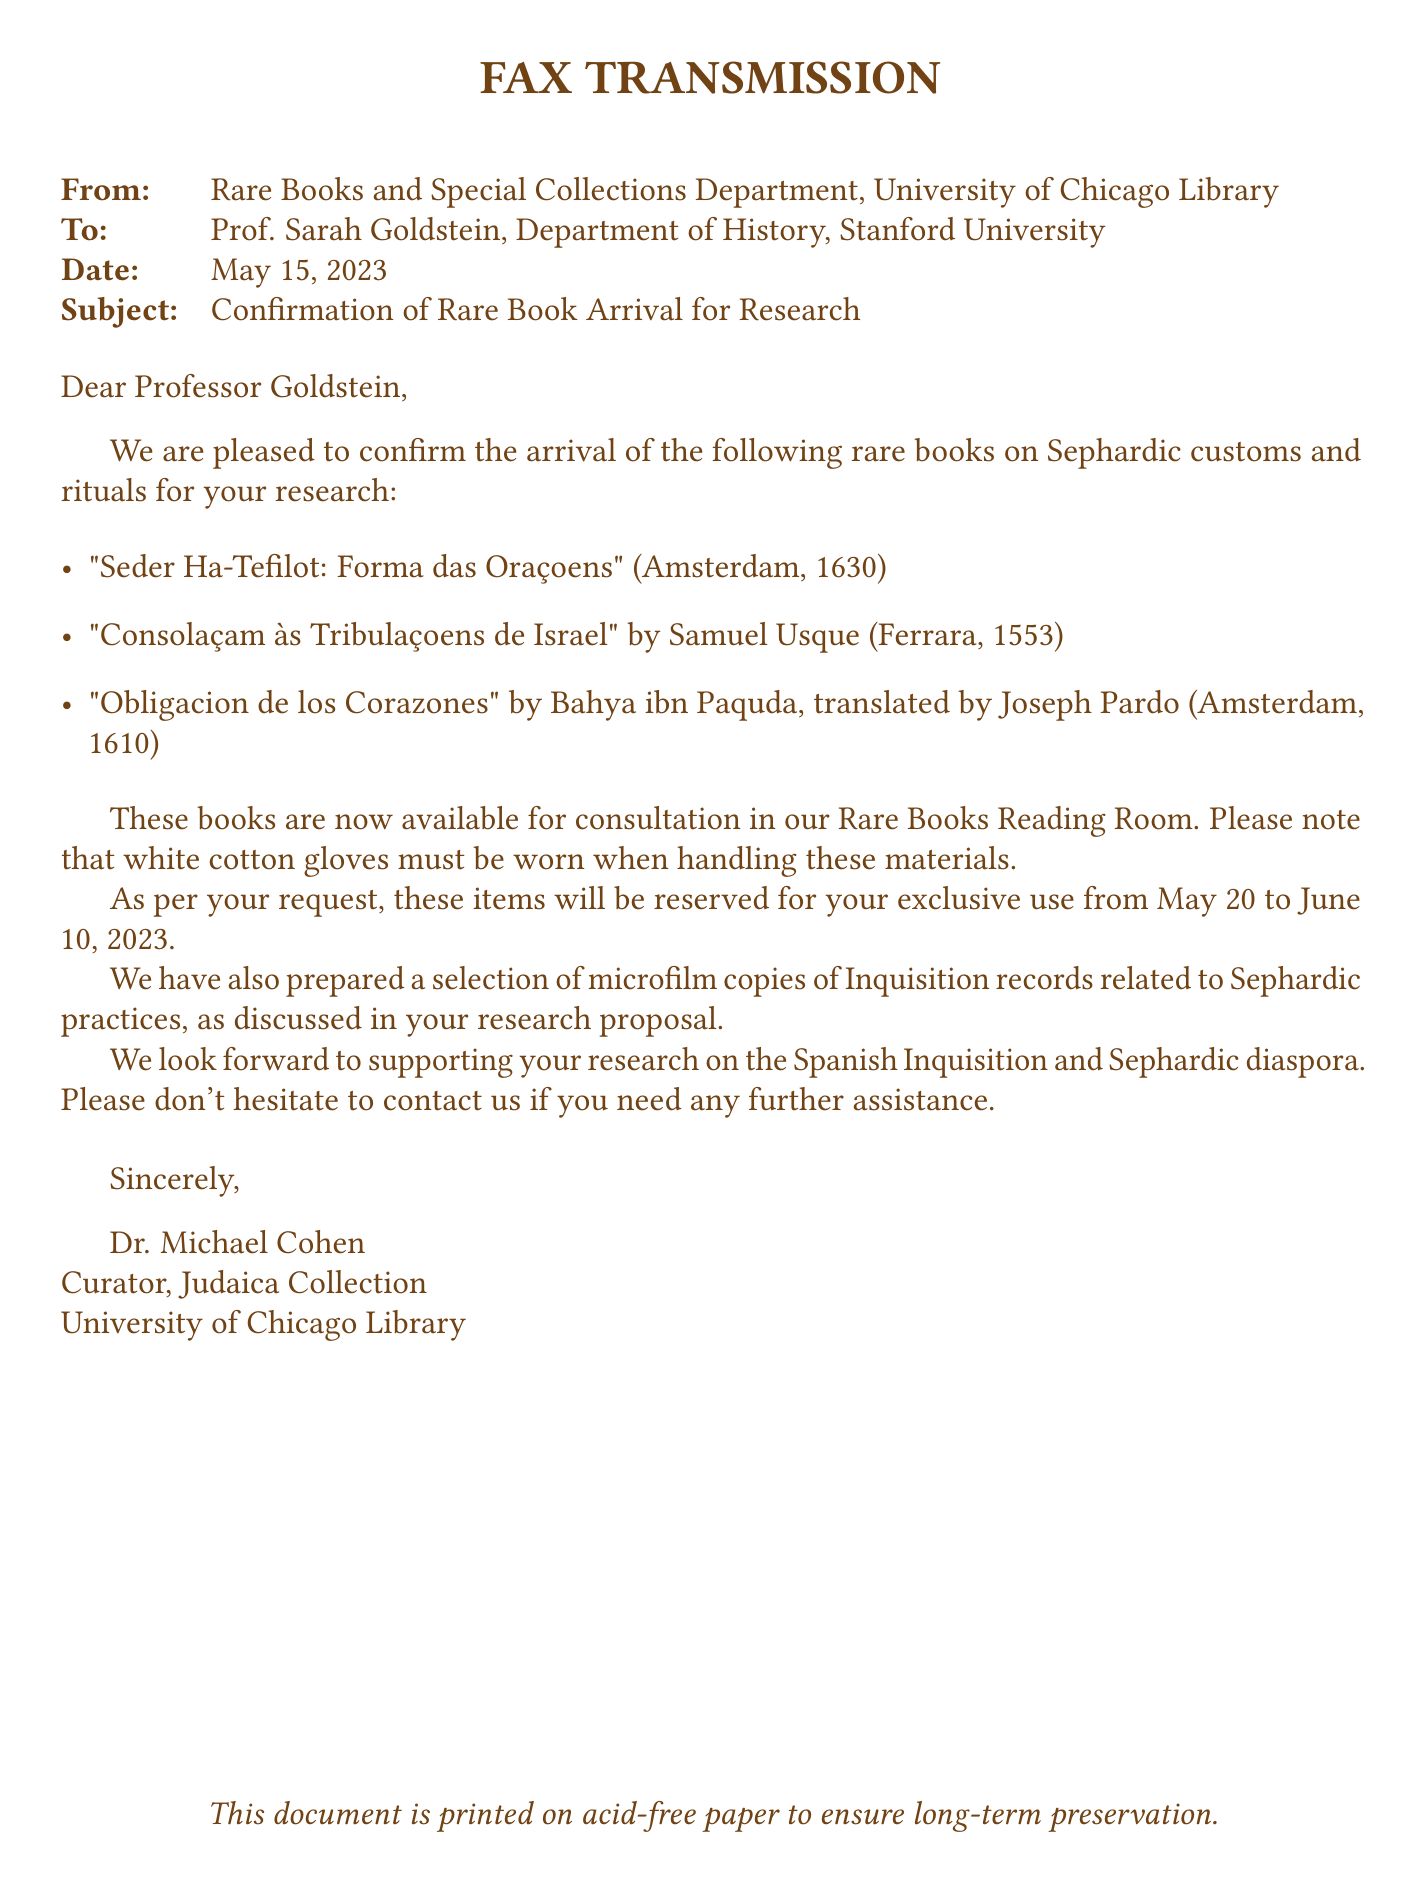What is the date of the fax? The date is explicitly mentioned in the document as May 15, 2023.
Answer: May 15, 2023 Who is the sender of the fax? The sender is listed at the top of the document as the Rare Books and Special Collections Department, University of Chicago Library.
Answer: Rare Books and Special Collections Department, University of Chicago Library What is the title of the book by Samuel Usque? The title is provided in the itemized list of books as "Consolaçam às Tribulaçoens de Israel."
Answer: Consolaçam às Tribulaçoens de Israel What must be worn when handling the rare books? The document clearly indicates that white cotton gloves must be worn.
Answer: White cotton gloves What is the reserved period for the books? The reserved period is specified in the text as May 20 to June 10, 2023.
Answer: May 20 to June 10, 2023 Who is the recipient of the fax? The recipient is stated as Prof. Sarah Goldstein, Department of History, Stanford University.
Answer: Prof. Sarah Goldstein What type of records were prepared in addition to the rare books? The text refers to microfilm copies of Inquisition records related to Sephardic practices.
Answer: Microfilm copies of Inquisition records 